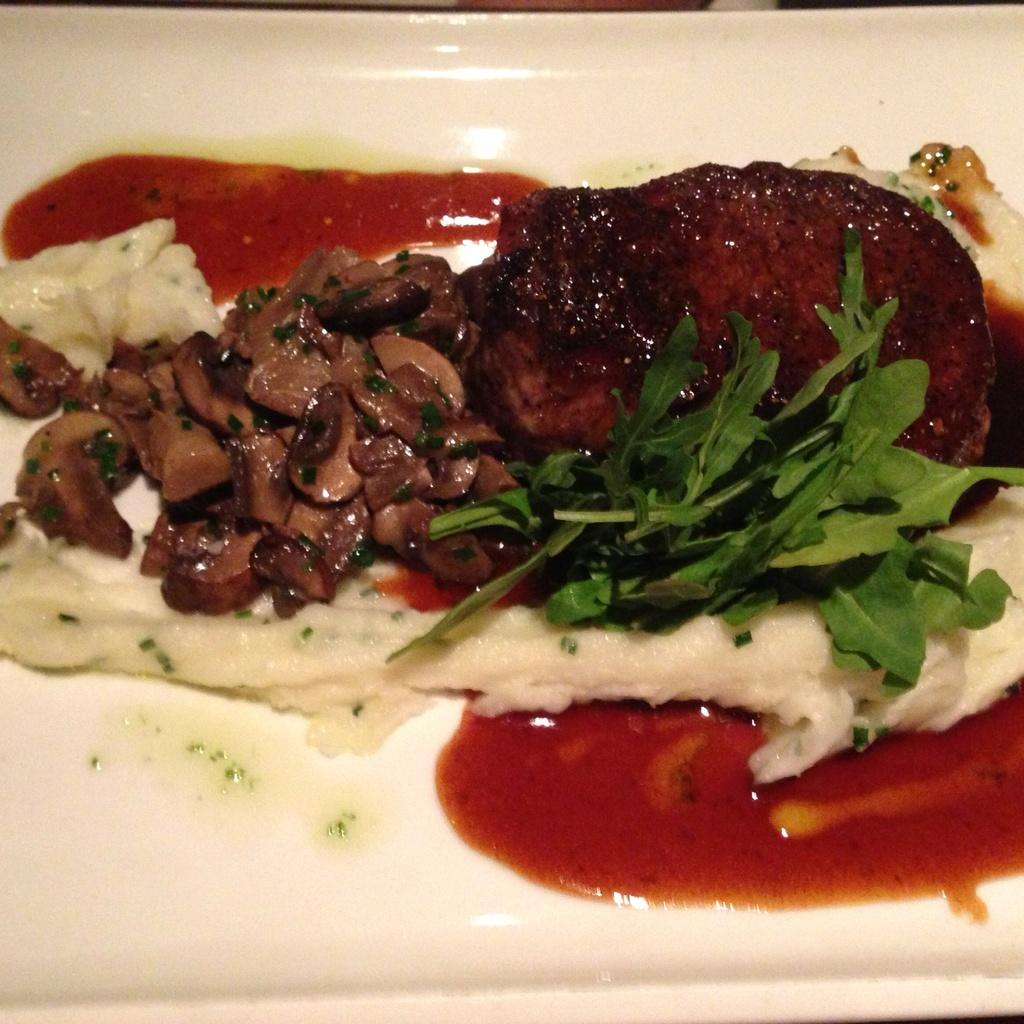What is the main subject on the plate in the image? There is a food item on a plate in the image. How many islands can be seen in the background of the image? There are no islands visible in the image; it only features a food item on a plate. What type of sock is being used as a prop in the image? There is no sock present in the image. 